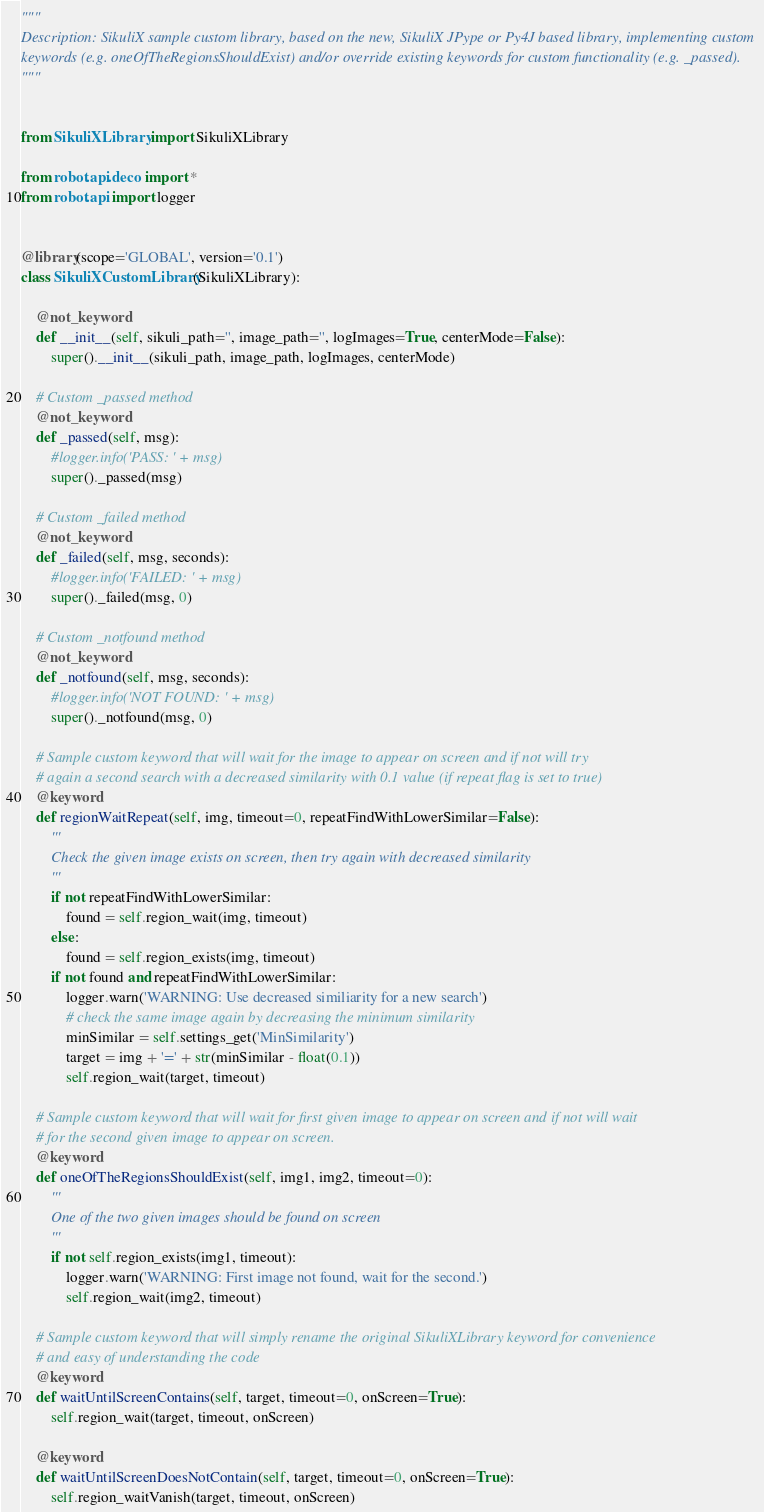Convert code to text. <code><loc_0><loc_0><loc_500><loc_500><_Python_>"""
Description: SikuliX sample custom library, based on the new, SikuliX JPype or Py4J based library, implementing custom 
keywords (e.g. oneOfTheRegionsShouldExist) and/or override existing keywords for custom functionality (e.g. _passed).
"""


from SikuliXLibrary import SikuliXLibrary

from robot.api.deco import *
from robot.api import logger


@library(scope='GLOBAL', version='0.1')
class SikuliXCustomLibrary(SikuliXLibrary):

    @not_keyword
    def __init__(self, sikuli_path='', image_path='', logImages=True, centerMode=False):
        super().__init__(sikuli_path, image_path, logImages, centerMode)

    # Custom _passed method
    @not_keyword
    def _passed(self, msg):
        #logger.info('PASS: ' + msg)
        super()._passed(msg)

    # Custom _failed method
    @not_keyword
    def _failed(self, msg, seconds):
        #logger.info('FAILED: ' + msg)
        super()._failed(msg, 0)

    # Custom _notfound method
    @not_keyword
    def _notfound(self, msg, seconds):
        #logger.info('NOT FOUND: ' + msg)
        super()._notfound(msg, 0)

    # Sample custom keyword that will wait for the image to appear on screen and if not will try 
    # again a second search with a decreased similarity with 0.1 value (if repeat flag is set to true)
    @keyword
    def regionWaitRepeat(self, img, timeout=0, repeatFindWithLowerSimilar=False):
        '''
        Check the given image exists on screen, then try again with decreased similarity
        '''
        if not repeatFindWithLowerSimilar:
            found = self.region_wait(img, timeout)
        else:
            found = self.region_exists(img, timeout)
        if not found and repeatFindWithLowerSimilar:
            logger.warn('WARNING: Use decreased similiarity for a new search')
            # check the same image again by decreasing the minimum similarity
            minSimilar = self.settings_get('MinSimilarity')
            target = img + '=' + str(minSimilar - float(0.1))
            self.region_wait(target, timeout)

    # Sample custom keyword that will wait for first given image to appear on screen and if not will wait
    # for the second given image to appear on screen.
    @keyword
    def oneOfTheRegionsShouldExist(self, img1, img2, timeout=0):
        '''
        One of the two given images should be found on screen
        '''
        if not self.region_exists(img1, timeout):        
            logger.warn('WARNING: First image not found, wait for the second.')
            self.region_wait(img2, timeout)

    # Sample custom keyword that will simply rename the original SikuliXLibrary keyword for convenience
    # and easy of understanding the code
    @keyword
    def waitUntilScreenContains(self, target, timeout=0, onScreen=True):
        self.region_wait(target, timeout, onScreen)

    @keyword
    def waitUntilScreenDoesNotContain(self, target, timeout=0, onScreen=True):
        self.region_waitVanish(target, timeout, onScreen)
</code> 